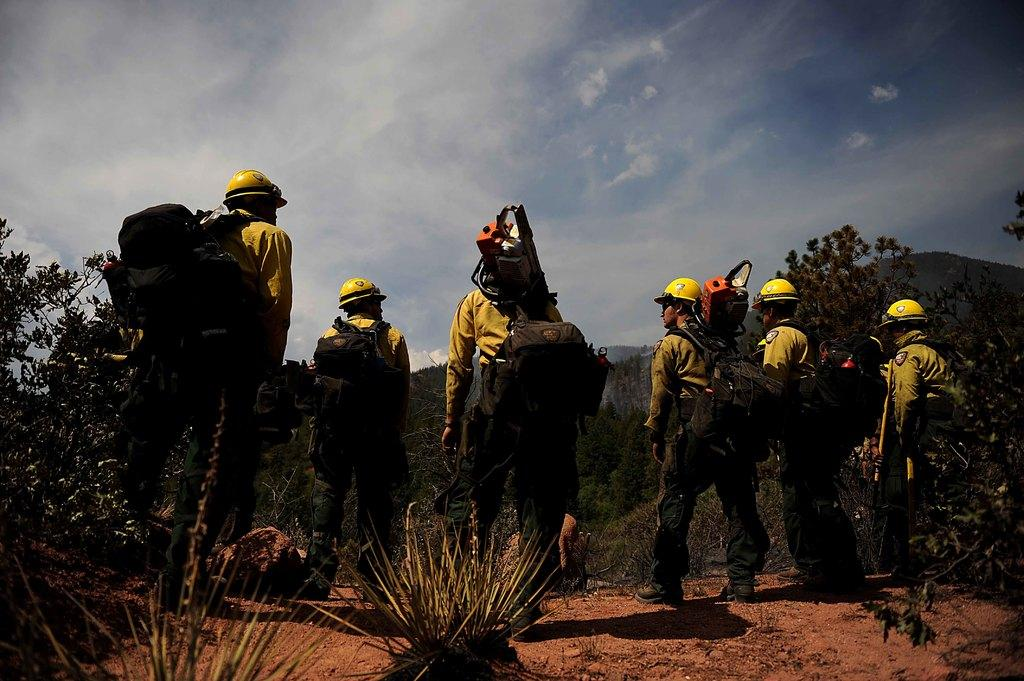What are the men in the image doing? The men are standing on the ground. What are the men wearing on their backs? The men are wearing backpacks. What can be seen in the background of the image? There are hills, trees, shrubs, stones, and the sky visible in the background of the image. What is the condition of the sky in the image? The sky is visible in the background of the image, and there are clouds present. What type of winter sport can be seen the men participating in the image? There is no winter sport or any indication of winter in the image; the men are simply standing on the ground with backpacks. What rhythm is the men following while standing in the image? There is no rhythm or any indication of a specific pattern in the way the men are standing in the image. 